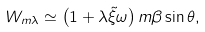Convert formula to latex. <formula><loc_0><loc_0><loc_500><loc_500>W _ { m \lambda } \simeq \left ( 1 + \lambda \tilde { \xi } \omega \right ) m \beta \sin \theta ,</formula> 